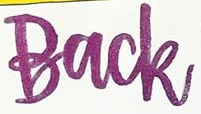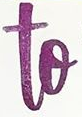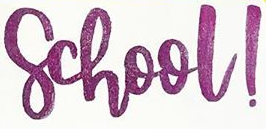Transcribe the words shown in these images in order, separated by a semicolon. Back; to; school! 